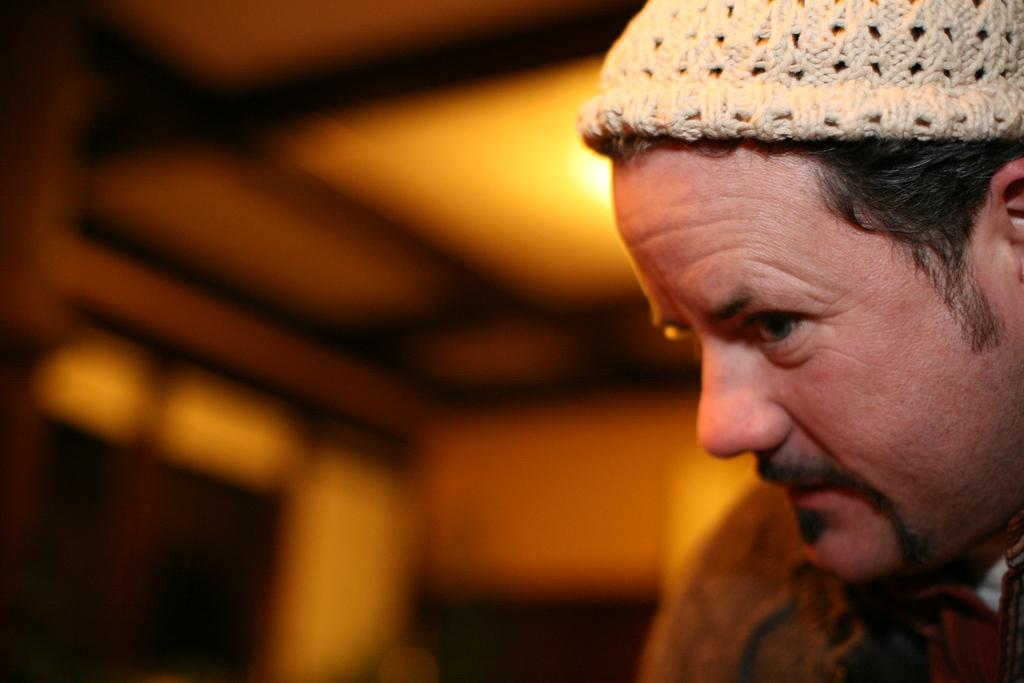Who or what is the main subject of the image? There is a person in the image. What is the person wearing on their head? The person is wearing a hat. Can you describe the background of the image? The background of the image is blurred. What type of iron can be seen in the person's hand in the image? There is no iron present in the image; the person is wearing a hat and standing in a blurred background. 